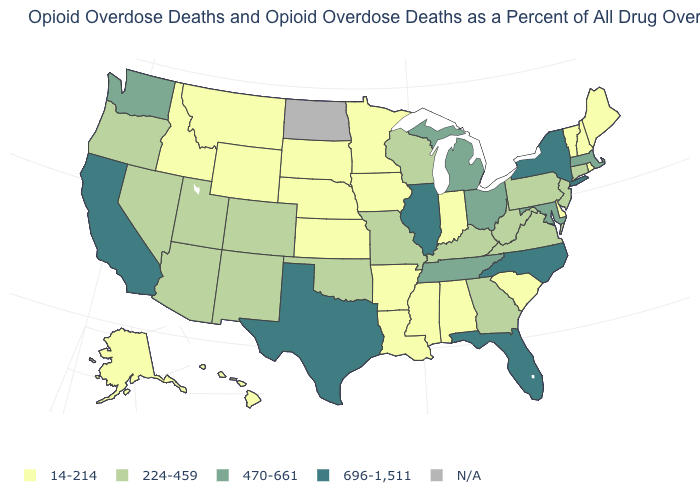What is the value of New Jersey?
Be succinct. 224-459. Is the legend a continuous bar?
Short answer required. No. Among the states that border Delaware , which have the lowest value?
Give a very brief answer. New Jersey, Pennsylvania. Among the states that border North Carolina , which have the highest value?
Give a very brief answer. Tennessee. Name the states that have a value in the range 224-459?
Answer briefly. Arizona, Colorado, Connecticut, Georgia, Kentucky, Missouri, Nevada, New Jersey, New Mexico, Oklahoma, Oregon, Pennsylvania, Utah, Virginia, West Virginia, Wisconsin. Among the states that border Mississippi , which have the highest value?
Write a very short answer. Tennessee. Does Michigan have the lowest value in the USA?
Be succinct. No. Name the states that have a value in the range N/A?
Answer briefly. North Dakota. What is the lowest value in the West?
Short answer required. 14-214. Name the states that have a value in the range 14-214?
Be succinct. Alabama, Alaska, Arkansas, Delaware, Hawaii, Idaho, Indiana, Iowa, Kansas, Louisiana, Maine, Minnesota, Mississippi, Montana, Nebraska, New Hampshire, Rhode Island, South Carolina, South Dakota, Vermont, Wyoming. What is the highest value in the Northeast ?
Answer briefly. 696-1,511. Does the map have missing data?
Write a very short answer. Yes. Among the states that border Pennsylvania , does New York have the highest value?
Be succinct. Yes. 